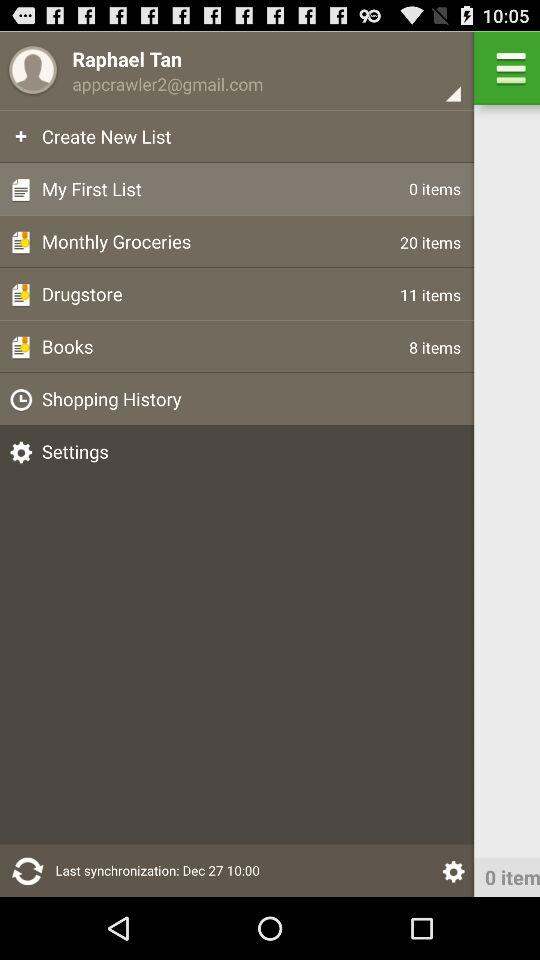How many items are there in the "Monthly Groceries" list? There are 20 items. 